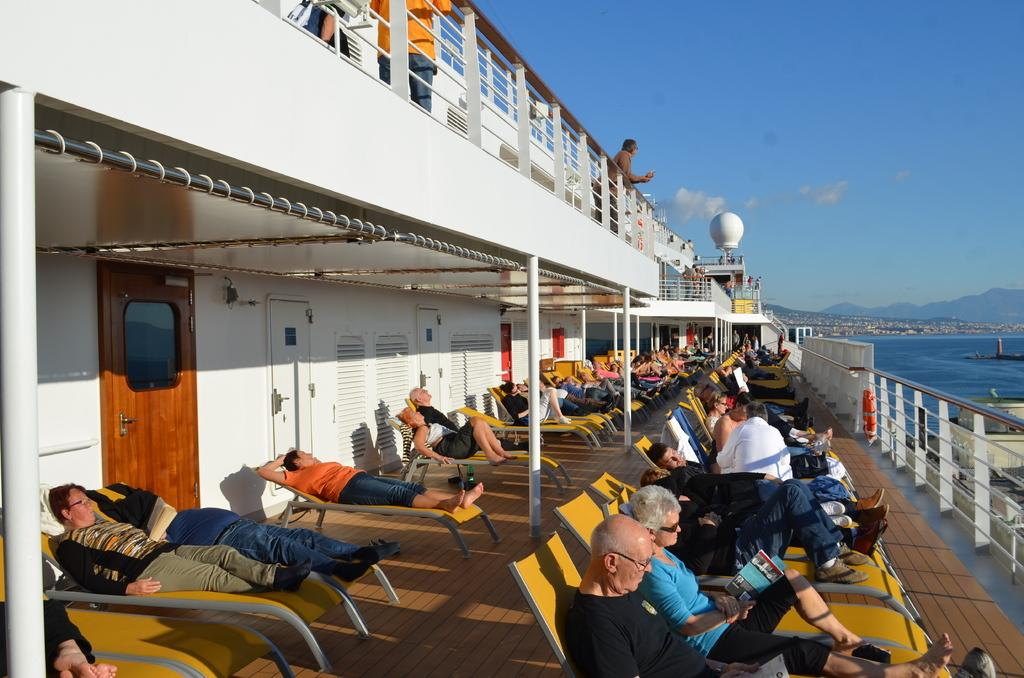What are the people in the image doing? The people in the image are lying on chairs on the left side of the image. What can be seen on the right side of the image? There is water visible on the right side of the image. What is the color of the sky in the image? The sky is blue in color and visible at the top of the image. What type of card is being used by the people in the image? There is no card present in the image; the people are lying on chairs and there is water visible on the right side. 